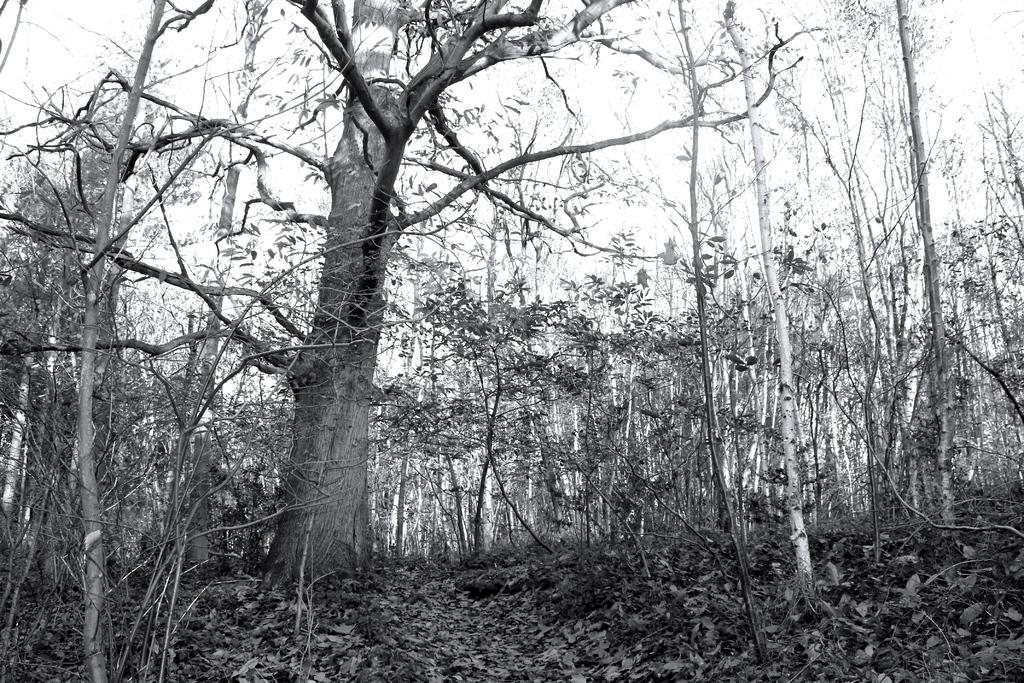What colors are used in the image? The image uses black and white. What type of natural elements can be seen in the image? There are trees and plants visible in the image. What is visible at the top of the image? The sky is visible at the top of the image. Where is the prison located in the image? There is no prison present in the image. What emotion can be seen on the trees in the image? Trees do not have emotions, so it is not possible to determine an emotion from the image. 